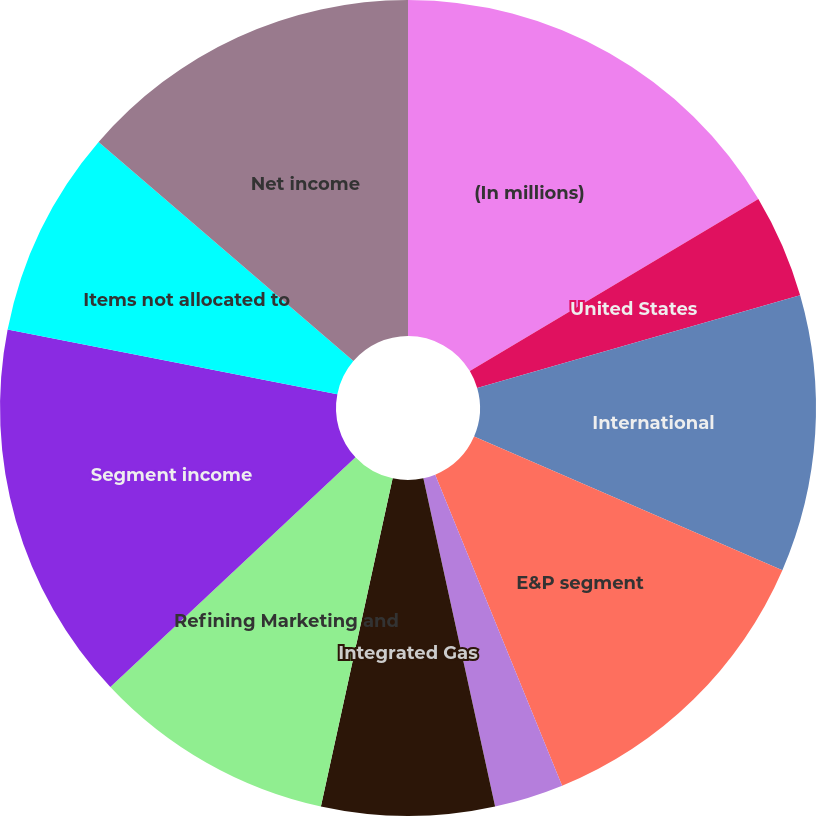<chart> <loc_0><loc_0><loc_500><loc_500><pie_chart><fcel>(In millions)<fcel>United States<fcel>International<fcel>E&P segment<fcel>Oil Sands Mining<fcel>Integrated Gas<fcel>Refining Marketing and<fcel>Segment income<fcel>Items not allocated to<fcel>Net income<nl><fcel>16.44%<fcel>4.11%<fcel>10.96%<fcel>12.33%<fcel>2.74%<fcel>6.85%<fcel>9.59%<fcel>15.07%<fcel>8.22%<fcel>13.7%<nl></chart> 